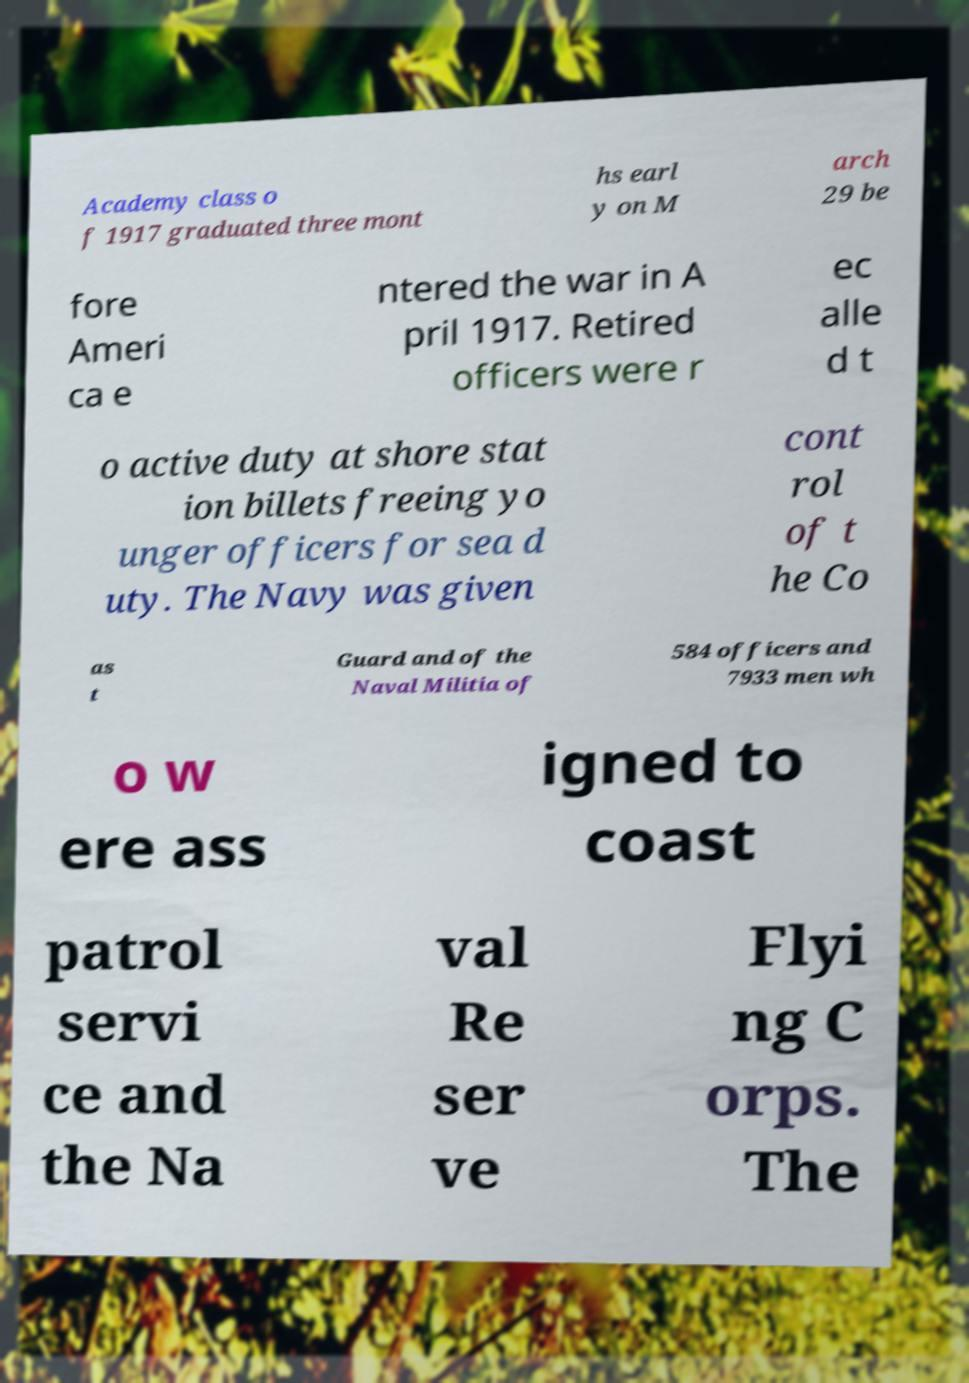For documentation purposes, I need the text within this image transcribed. Could you provide that? Academy class o f 1917 graduated three mont hs earl y on M arch 29 be fore Ameri ca e ntered the war in A pril 1917. Retired officers were r ec alle d t o active duty at shore stat ion billets freeing yo unger officers for sea d uty. The Navy was given cont rol of t he Co as t Guard and of the Naval Militia of 584 officers and 7933 men wh o w ere ass igned to coast patrol servi ce and the Na val Re ser ve Flyi ng C orps. The 